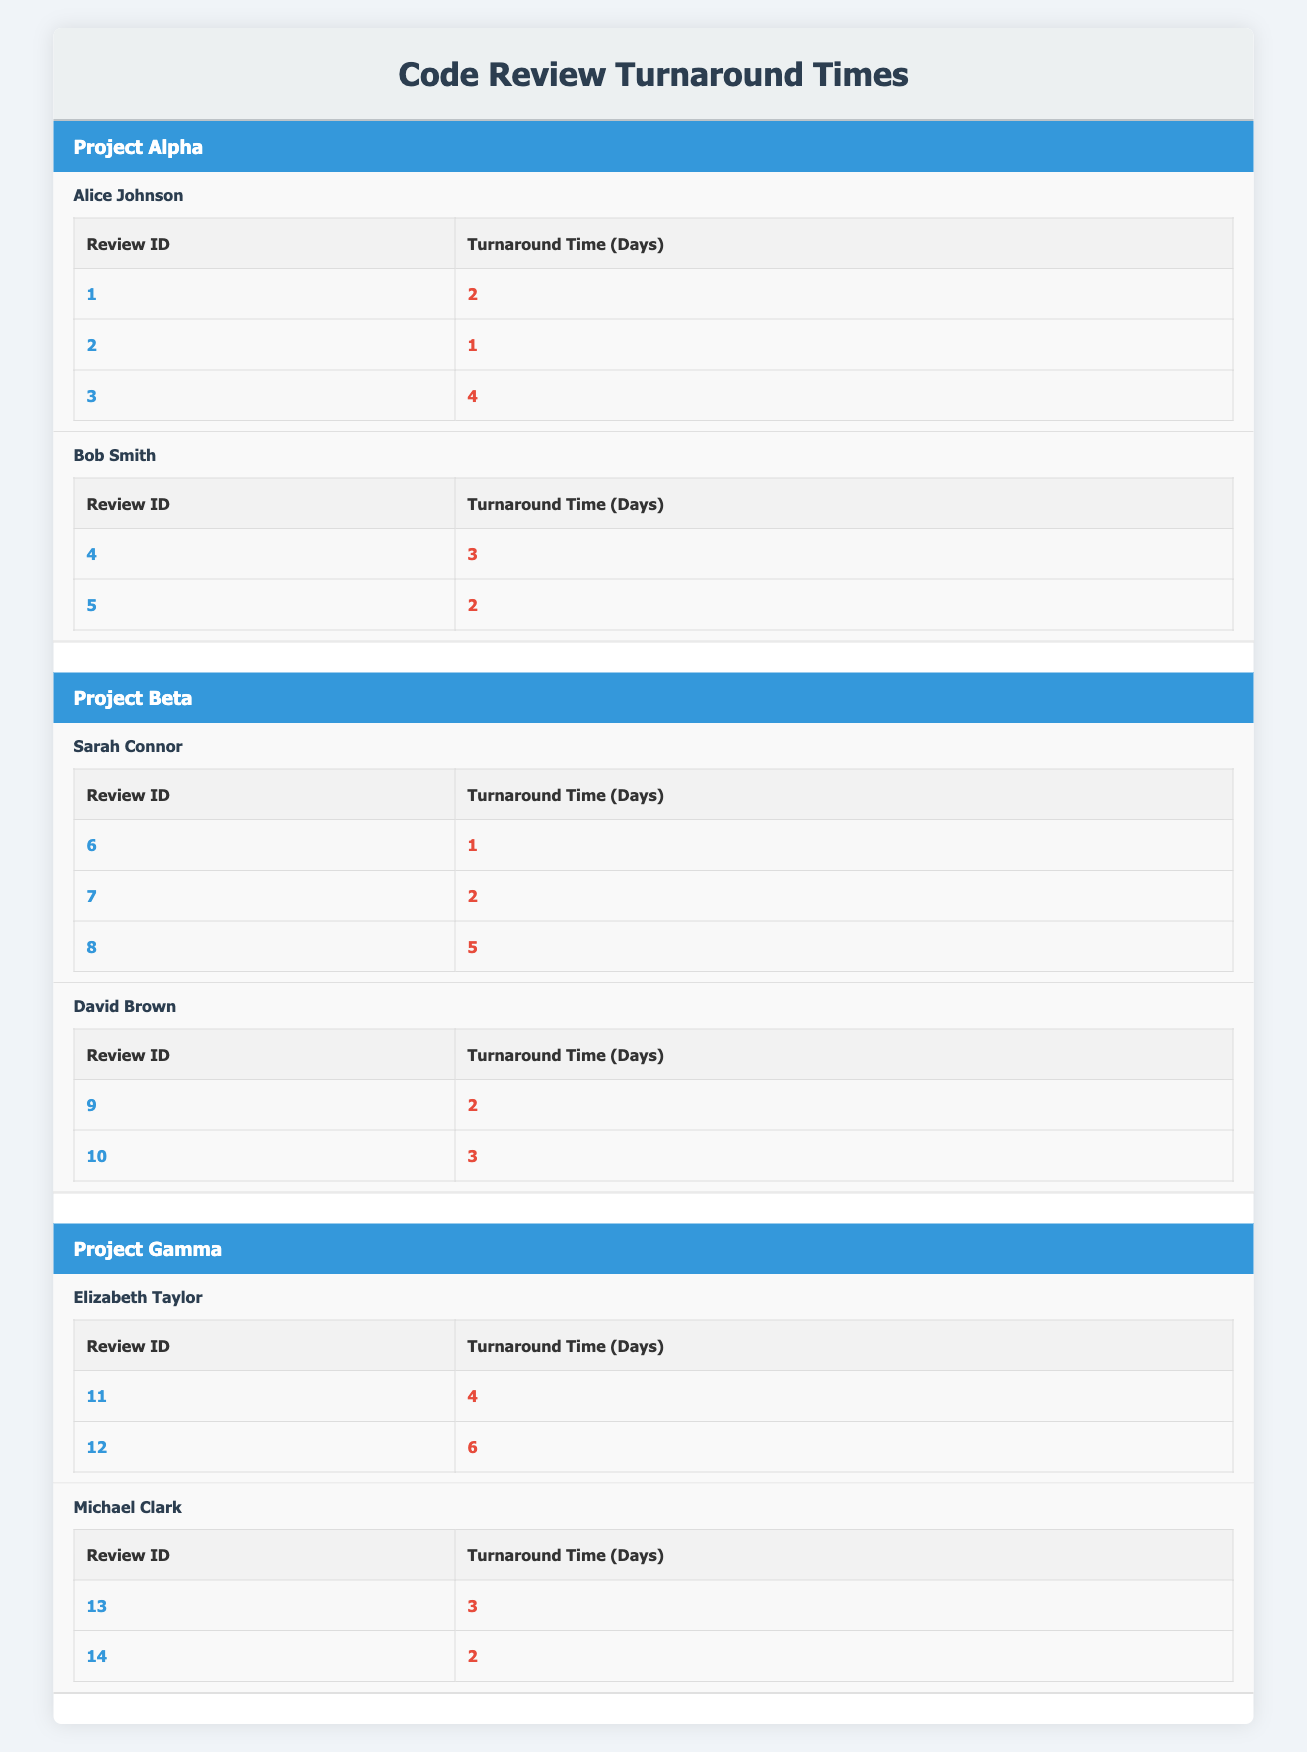What is the turnaround time for review ID 3? The table shows that for review ID 3, the turnaround time is listed as 4 days under Alice Johnson's reviews in Project Alpha.
Answer: 4 days Who took the shortest time to review in Project Beta? In Project Beta, Sarah Connor reviewed review ID 6 in 1 day, which is the shortest time recorded among all reviewers in this project.
Answer: Sarah Connor What is the average turnaround time for Alice Johnson's reviews? To calculate the average for Alice Johnson’s reviews, sum the turnaround times: 2 + 1 + 4 = 7 days. Then divide by the number of reviews: 7/3 ≈ 2.33 days.
Answer: Approximately 2.33 days Did Michael Clark have any reviews that took more than 3 days? Looking at Michael Clark's reviews, he took 3 days for review ID 13 and 2 days for review ID 14, which means he did not have any reviews taking more than 3 days.
Answer: No What is the total number of days taken by all reviewers in Project Gamma? For Project Gamma, Elizabeth Taylor's reviews took 4 days and 6 days (totaling 10 days), while Michael Clark's took 3 days and 2 days (totaling 5 days). Adding these totals gives 10 + 5 = 15 days.
Answer: 15 days Which reviewer had the highest individual review turnaround time across all projects? By inspecting the table, Elizabeth Taylor's review ID 12 took the longest at 6 days, which is the highest individual turnaround time among all reviewers.
Answer: Elizabeth Taylor What is the combined turnaround time for David Brown's reviews? David Brown's reviews took 2 days (review ID 9) and 3 days (review ID 10). Summing these values gives 2 + 3 = 5 days as the total turnaround time for him.
Answer: 5 days Which project had the longest single review turnaround time? The longest single review turnaround time recorded in the table is 6 days for Elizabeth Taylor's review ID 12 in Project Gamma.
Answer: Project Gamma What is the average turnaround time for all reviewers in Project Alpha? In Project Alpha, Alice Johnson's reviews have turnaround times totaling 4 + 2 + 1 = 7 days (for 3 reviews) and Bob Smith’s reviews total 3 + 2 = 5 days (for 2 reviews). The grand total is 7 + 5 = 12 days from 5 reviews, giving an average of 12/5 = 2.4 days.
Answer: 2.4 days 